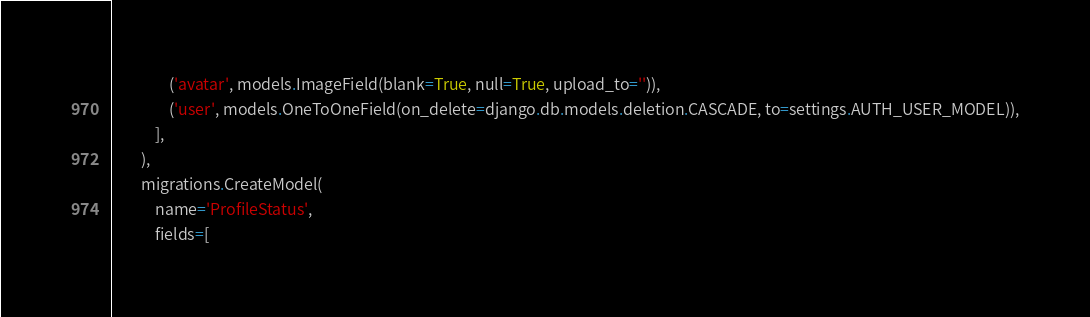<code> <loc_0><loc_0><loc_500><loc_500><_Python_>                ('avatar', models.ImageField(blank=True, null=True, upload_to='')),
                ('user', models.OneToOneField(on_delete=django.db.models.deletion.CASCADE, to=settings.AUTH_USER_MODEL)),
            ],
        ),
        migrations.CreateModel(
            name='ProfileStatus',
            fields=[</code> 